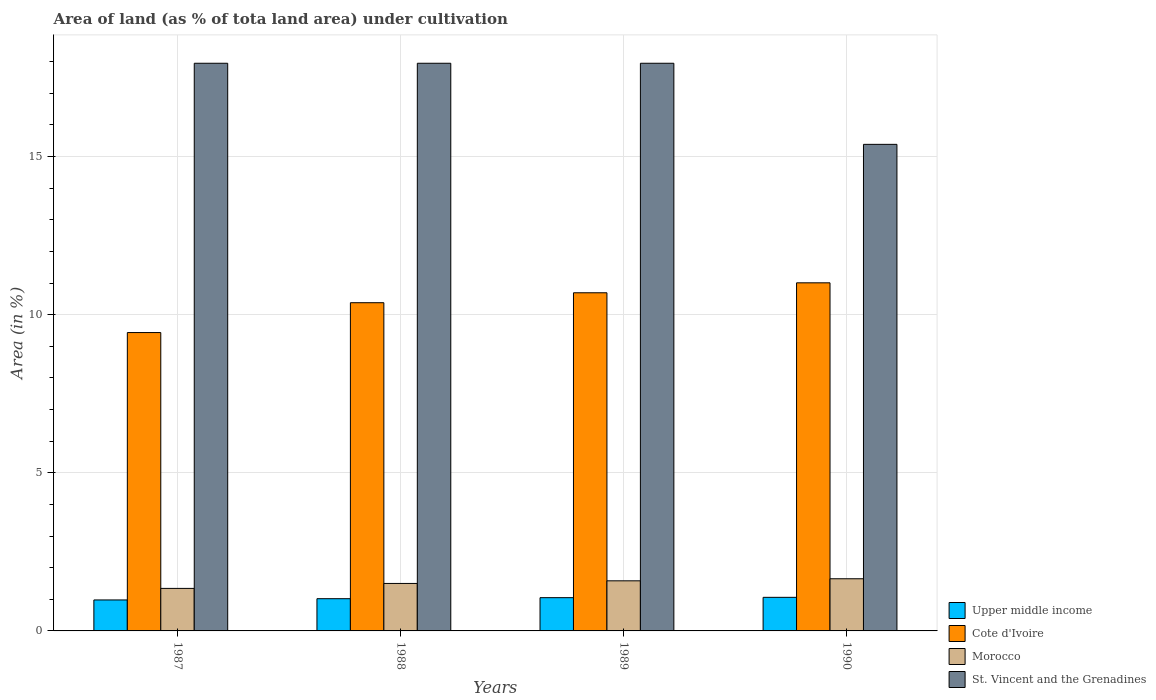Are the number of bars on each tick of the X-axis equal?
Your answer should be compact. Yes. What is the percentage of land under cultivation in Upper middle income in 1989?
Your answer should be very brief. 1.05. Across all years, what is the maximum percentage of land under cultivation in Cote d'Ivoire?
Provide a succinct answer. 11.01. Across all years, what is the minimum percentage of land under cultivation in Morocco?
Provide a short and direct response. 1.34. In which year was the percentage of land under cultivation in Upper middle income maximum?
Provide a short and direct response. 1990. In which year was the percentage of land under cultivation in Upper middle income minimum?
Your answer should be compact. 1987. What is the total percentage of land under cultivation in Upper middle income in the graph?
Offer a terse response. 4.11. What is the difference between the percentage of land under cultivation in Morocco in 1989 and that in 1990?
Keep it short and to the point. -0.06. What is the difference between the percentage of land under cultivation in Upper middle income in 1989 and the percentage of land under cultivation in St. Vincent and the Grenadines in 1990?
Your answer should be compact. -14.33. What is the average percentage of land under cultivation in Morocco per year?
Offer a very short reply. 1.52. In the year 1987, what is the difference between the percentage of land under cultivation in Morocco and percentage of land under cultivation in Upper middle income?
Give a very brief answer. 0.37. In how many years, is the percentage of land under cultivation in St. Vincent and the Grenadines greater than 9 %?
Your answer should be very brief. 4. What is the difference between the highest and the second highest percentage of land under cultivation in Morocco?
Provide a succinct answer. 0.06. What is the difference between the highest and the lowest percentage of land under cultivation in Morocco?
Offer a terse response. 0.3. Is the sum of the percentage of land under cultivation in Morocco in 1987 and 1989 greater than the maximum percentage of land under cultivation in Cote d'Ivoire across all years?
Your answer should be very brief. No. Is it the case that in every year, the sum of the percentage of land under cultivation in Morocco and percentage of land under cultivation in Cote d'Ivoire is greater than the sum of percentage of land under cultivation in St. Vincent and the Grenadines and percentage of land under cultivation in Upper middle income?
Offer a terse response. Yes. What does the 1st bar from the left in 1989 represents?
Provide a succinct answer. Upper middle income. What does the 4th bar from the right in 1988 represents?
Make the answer very short. Upper middle income. Is it the case that in every year, the sum of the percentage of land under cultivation in Morocco and percentage of land under cultivation in Upper middle income is greater than the percentage of land under cultivation in Cote d'Ivoire?
Offer a very short reply. No. Are the values on the major ticks of Y-axis written in scientific E-notation?
Ensure brevity in your answer.  No. Does the graph contain any zero values?
Keep it short and to the point. No. Where does the legend appear in the graph?
Keep it short and to the point. Bottom right. What is the title of the graph?
Give a very brief answer. Area of land (as % of tota land area) under cultivation. Does "Cayman Islands" appear as one of the legend labels in the graph?
Give a very brief answer. No. What is the label or title of the X-axis?
Keep it short and to the point. Years. What is the label or title of the Y-axis?
Offer a very short reply. Area (in %). What is the Area (in %) in Upper middle income in 1987?
Your answer should be very brief. 0.98. What is the Area (in %) of Cote d'Ivoire in 1987?
Make the answer very short. 9.43. What is the Area (in %) in Morocco in 1987?
Your answer should be very brief. 1.34. What is the Area (in %) of St. Vincent and the Grenadines in 1987?
Offer a terse response. 17.95. What is the Area (in %) of Upper middle income in 1988?
Your response must be concise. 1.02. What is the Area (in %) of Cote d'Ivoire in 1988?
Ensure brevity in your answer.  10.38. What is the Area (in %) in Morocco in 1988?
Offer a terse response. 1.5. What is the Area (in %) of St. Vincent and the Grenadines in 1988?
Offer a terse response. 17.95. What is the Area (in %) in Upper middle income in 1989?
Your answer should be very brief. 1.05. What is the Area (in %) in Cote d'Ivoire in 1989?
Your response must be concise. 10.69. What is the Area (in %) in Morocco in 1989?
Your answer should be compact. 1.58. What is the Area (in %) in St. Vincent and the Grenadines in 1989?
Provide a succinct answer. 17.95. What is the Area (in %) in Upper middle income in 1990?
Give a very brief answer. 1.06. What is the Area (in %) in Cote d'Ivoire in 1990?
Provide a succinct answer. 11.01. What is the Area (in %) of Morocco in 1990?
Offer a terse response. 1.65. What is the Area (in %) of St. Vincent and the Grenadines in 1990?
Make the answer very short. 15.38. Across all years, what is the maximum Area (in %) of Upper middle income?
Provide a short and direct response. 1.06. Across all years, what is the maximum Area (in %) of Cote d'Ivoire?
Keep it short and to the point. 11.01. Across all years, what is the maximum Area (in %) in Morocco?
Provide a succinct answer. 1.65. Across all years, what is the maximum Area (in %) in St. Vincent and the Grenadines?
Offer a very short reply. 17.95. Across all years, what is the minimum Area (in %) of Upper middle income?
Provide a succinct answer. 0.98. Across all years, what is the minimum Area (in %) in Cote d'Ivoire?
Your answer should be compact. 9.43. Across all years, what is the minimum Area (in %) in Morocco?
Keep it short and to the point. 1.34. Across all years, what is the minimum Area (in %) in St. Vincent and the Grenadines?
Your answer should be compact. 15.38. What is the total Area (in %) of Upper middle income in the graph?
Make the answer very short. 4.11. What is the total Area (in %) in Cote d'Ivoire in the graph?
Offer a terse response. 41.51. What is the total Area (in %) of Morocco in the graph?
Provide a succinct answer. 6.08. What is the total Area (in %) of St. Vincent and the Grenadines in the graph?
Make the answer very short. 69.23. What is the difference between the Area (in %) of Upper middle income in 1987 and that in 1988?
Offer a very short reply. -0.04. What is the difference between the Area (in %) in Cote d'Ivoire in 1987 and that in 1988?
Provide a short and direct response. -0.94. What is the difference between the Area (in %) of Morocco in 1987 and that in 1988?
Keep it short and to the point. -0.16. What is the difference between the Area (in %) in Upper middle income in 1987 and that in 1989?
Give a very brief answer. -0.07. What is the difference between the Area (in %) in Cote d'Ivoire in 1987 and that in 1989?
Give a very brief answer. -1.26. What is the difference between the Area (in %) of Morocco in 1987 and that in 1989?
Offer a very short reply. -0.24. What is the difference between the Area (in %) in St. Vincent and the Grenadines in 1987 and that in 1989?
Keep it short and to the point. 0. What is the difference between the Area (in %) in Upper middle income in 1987 and that in 1990?
Offer a terse response. -0.08. What is the difference between the Area (in %) of Cote d'Ivoire in 1987 and that in 1990?
Ensure brevity in your answer.  -1.57. What is the difference between the Area (in %) in Morocco in 1987 and that in 1990?
Provide a short and direct response. -0.3. What is the difference between the Area (in %) in St. Vincent and the Grenadines in 1987 and that in 1990?
Offer a terse response. 2.56. What is the difference between the Area (in %) of Upper middle income in 1988 and that in 1989?
Keep it short and to the point. -0.03. What is the difference between the Area (in %) of Cote d'Ivoire in 1988 and that in 1989?
Keep it short and to the point. -0.31. What is the difference between the Area (in %) in Morocco in 1988 and that in 1989?
Offer a terse response. -0.08. What is the difference between the Area (in %) of Upper middle income in 1988 and that in 1990?
Your answer should be compact. -0.04. What is the difference between the Area (in %) in Cote d'Ivoire in 1988 and that in 1990?
Keep it short and to the point. -0.63. What is the difference between the Area (in %) in Morocco in 1988 and that in 1990?
Keep it short and to the point. -0.15. What is the difference between the Area (in %) of St. Vincent and the Grenadines in 1988 and that in 1990?
Provide a short and direct response. 2.56. What is the difference between the Area (in %) of Upper middle income in 1989 and that in 1990?
Offer a terse response. -0.01. What is the difference between the Area (in %) of Cote d'Ivoire in 1989 and that in 1990?
Your answer should be very brief. -0.31. What is the difference between the Area (in %) of Morocco in 1989 and that in 1990?
Your answer should be very brief. -0.07. What is the difference between the Area (in %) of St. Vincent and the Grenadines in 1989 and that in 1990?
Offer a terse response. 2.56. What is the difference between the Area (in %) of Upper middle income in 1987 and the Area (in %) of Cote d'Ivoire in 1988?
Your answer should be compact. -9.4. What is the difference between the Area (in %) in Upper middle income in 1987 and the Area (in %) in Morocco in 1988?
Offer a very short reply. -0.52. What is the difference between the Area (in %) of Upper middle income in 1987 and the Area (in %) of St. Vincent and the Grenadines in 1988?
Make the answer very short. -16.97. What is the difference between the Area (in %) of Cote d'Ivoire in 1987 and the Area (in %) of Morocco in 1988?
Offer a very short reply. 7.93. What is the difference between the Area (in %) in Cote d'Ivoire in 1987 and the Area (in %) in St. Vincent and the Grenadines in 1988?
Your answer should be compact. -8.51. What is the difference between the Area (in %) in Morocco in 1987 and the Area (in %) in St. Vincent and the Grenadines in 1988?
Make the answer very short. -16.6. What is the difference between the Area (in %) in Upper middle income in 1987 and the Area (in %) in Cote d'Ivoire in 1989?
Offer a terse response. -9.71. What is the difference between the Area (in %) in Upper middle income in 1987 and the Area (in %) in Morocco in 1989?
Your response must be concise. -0.6. What is the difference between the Area (in %) in Upper middle income in 1987 and the Area (in %) in St. Vincent and the Grenadines in 1989?
Provide a short and direct response. -16.97. What is the difference between the Area (in %) in Cote d'Ivoire in 1987 and the Area (in %) in Morocco in 1989?
Ensure brevity in your answer.  7.85. What is the difference between the Area (in %) of Cote d'Ivoire in 1987 and the Area (in %) of St. Vincent and the Grenadines in 1989?
Your response must be concise. -8.51. What is the difference between the Area (in %) of Morocco in 1987 and the Area (in %) of St. Vincent and the Grenadines in 1989?
Your answer should be compact. -16.6. What is the difference between the Area (in %) of Upper middle income in 1987 and the Area (in %) of Cote d'Ivoire in 1990?
Provide a short and direct response. -10.03. What is the difference between the Area (in %) of Upper middle income in 1987 and the Area (in %) of Morocco in 1990?
Provide a short and direct response. -0.67. What is the difference between the Area (in %) of Upper middle income in 1987 and the Area (in %) of St. Vincent and the Grenadines in 1990?
Provide a short and direct response. -14.41. What is the difference between the Area (in %) in Cote d'Ivoire in 1987 and the Area (in %) in Morocco in 1990?
Give a very brief answer. 7.78. What is the difference between the Area (in %) in Cote d'Ivoire in 1987 and the Area (in %) in St. Vincent and the Grenadines in 1990?
Provide a succinct answer. -5.95. What is the difference between the Area (in %) in Morocco in 1987 and the Area (in %) in St. Vincent and the Grenadines in 1990?
Offer a very short reply. -14.04. What is the difference between the Area (in %) of Upper middle income in 1988 and the Area (in %) of Cote d'Ivoire in 1989?
Ensure brevity in your answer.  -9.67. What is the difference between the Area (in %) of Upper middle income in 1988 and the Area (in %) of Morocco in 1989?
Your answer should be compact. -0.57. What is the difference between the Area (in %) in Upper middle income in 1988 and the Area (in %) in St. Vincent and the Grenadines in 1989?
Offer a terse response. -16.93. What is the difference between the Area (in %) in Cote d'Ivoire in 1988 and the Area (in %) in Morocco in 1989?
Offer a very short reply. 8.79. What is the difference between the Area (in %) of Cote d'Ivoire in 1988 and the Area (in %) of St. Vincent and the Grenadines in 1989?
Offer a very short reply. -7.57. What is the difference between the Area (in %) of Morocco in 1988 and the Area (in %) of St. Vincent and the Grenadines in 1989?
Your answer should be very brief. -16.45. What is the difference between the Area (in %) in Upper middle income in 1988 and the Area (in %) in Cote d'Ivoire in 1990?
Your response must be concise. -9.99. What is the difference between the Area (in %) in Upper middle income in 1988 and the Area (in %) in Morocco in 1990?
Ensure brevity in your answer.  -0.63. What is the difference between the Area (in %) in Upper middle income in 1988 and the Area (in %) in St. Vincent and the Grenadines in 1990?
Your answer should be compact. -14.37. What is the difference between the Area (in %) of Cote d'Ivoire in 1988 and the Area (in %) of Morocco in 1990?
Your answer should be very brief. 8.73. What is the difference between the Area (in %) of Cote d'Ivoire in 1988 and the Area (in %) of St. Vincent and the Grenadines in 1990?
Your answer should be very brief. -5.01. What is the difference between the Area (in %) of Morocco in 1988 and the Area (in %) of St. Vincent and the Grenadines in 1990?
Your answer should be compact. -13.88. What is the difference between the Area (in %) in Upper middle income in 1989 and the Area (in %) in Cote d'Ivoire in 1990?
Offer a terse response. -9.95. What is the difference between the Area (in %) of Upper middle income in 1989 and the Area (in %) of Morocco in 1990?
Give a very brief answer. -0.6. What is the difference between the Area (in %) of Upper middle income in 1989 and the Area (in %) of St. Vincent and the Grenadines in 1990?
Ensure brevity in your answer.  -14.33. What is the difference between the Area (in %) of Cote d'Ivoire in 1989 and the Area (in %) of Morocco in 1990?
Make the answer very short. 9.04. What is the difference between the Area (in %) of Cote d'Ivoire in 1989 and the Area (in %) of St. Vincent and the Grenadines in 1990?
Your answer should be compact. -4.69. What is the difference between the Area (in %) of Morocco in 1989 and the Area (in %) of St. Vincent and the Grenadines in 1990?
Give a very brief answer. -13.8. What is the average Area (in %) in Upper middle income per year?
Provide a succinct answer. 1.03. What is the average Area (in %) in Cote d'Ivoire per year?
Your answer should be compact. 10.38. What is the average Area (in %) in Morocco per year?
Your answer should be compact. 1.52. What is the average Area (in %) in St. Vincent and the Grenadines per year?
Ensure brevity in your answer.  17.31. In the year 1987, what is the difference between the Area (in %) in Upper middle income and Area (in %) in Cote d'Ivoire?
Your answer should be very brief. -8.45. In the year 1987, what is the difference between the Area (in %) of Upper middle income and Area (in %) of Morocco?
Provide a short and direct response. -0.36. In the year 1987, what is the difference between the Area (in %) in Upper middle income and Area (in %) in St. Vincent and the Grenadines?
Offer a terse response. -16.97. In the year 1987, what is the difference between the Area (in %) of Cote d'Ivoire and Area (in %) of Morocco?
Ensure brevity in your answer.  8.09. In the year 1987, what is the difference between the Area (in %) of Cote d'Ivoire and Area (in %) of St. Vincent and the Grenadines?
Give a very brief answer. -8.51. In the year 1987, what is the difference between the Area (in %) in Morocco and Area (in %) in St. Vincent and the Grenadines?
Provide a succinct answer. -16.6. In the year 1988, what is the difference between the Area (in %) in Upper middle income and Area (in %) in Cote d'Ivoire?
Your answer should be very brief. -9.36. In the year 1988, what is the difference between the Area (in %) in Upper middle income and Area (in %) in Morocco?
Provide a succinct answer. -0.48. In the year 1988, what is the difference between the Area (in %) in Upper middle income and Area (in %) in St. Vincent and the Grenadines?
Offer a terse response. -16.93. In the year 1988, what is the difference between the Area (in %) of Cote d'Ivoire and Area (in %) of Morocco?
Keep it short and to the point. 8.88. In the year 1988, what is the difference between the Area (in %) of Cote d'Ivoire and Area (in %) of St. Vincent and the Grenadines?
Give a very brief answer. -7.57. In the year 1988, what is the difference between the Area (in %) of Morocco and Area (in %) of St. Vincent and the Grenadines?
Offer a terse response. -16.45. In the year 1989, what is the difference between the Area (in %) of Upper middle income and Area (in %) of Cote d'Ivoire?
Provide a short and direct response. -9.64. In the year 1989, what is the difference between the Area (in %) of Upper middle income and Area (in %) of Morocco?
Give a very brief answer. -0.53. In the year 1989, what is the difference between the Area (in %) of Upper middle income and Area (in %) of St. Vincent and the Grenadines?
Provide a succinct answer. -16.9. In the year 1989, what is the difference between the Area (in %) of Cote d'Ivoire and Area (in %) of Morocco?
Keep it short and to the point. 9.11. In the year 1989, what is the difference between the Area (in %) in Cote d'Ivoire and Area (in %) in St. Vincent and the Grenadines?
Provide a short and direct response. -7.26. In the year 1989, what is the difference between the Area (in %) in Morocco and Area (in %) in St. Vincent and the Grenadines?
Offer a very short reply. -16.36. In the year 1990, what is the difference between the Area (in %) in Upper middle income and Area (in %) in Cote d'Ivoire?
Provide a succinct answer. -9.94. In the year 1990, what is the difference between the Area (in %) in Upper middle income and Area (in %) in Morocco?
Your response must be concise. -0.59. In the year 1990, what is the difference between the Area (in %) in Upper middle income and Area (in %) in St. Vincent and the Grenadines?
Make the answer very short. -14.32. In the year 1990, what is the difference between the Area (in %) in Cote d'Ivoire and Area (in %) in Morocco?
Offer a very short reply. 9.36. In the year 1990, what is the difference between the Area (in %) in Cote d'Ivoire and Area (in %) in St. Vincent and the Grenadines?
Give a very brief answer. -4.38. In the year 1990, what is the difference between the Area (in %) of Morocco and Area (in %) of St. Vincent and the Grenadines?
Offer a terse response. -13.74. What is the ratio of the Area (in %) of Upper middle income in 1987 to that in 1988?
Make the answer very short. 0.96. What is the ratio of the Area (in %) in Morocco in 1987 to that in 1988?
Provide a succinct answer. 0.9. What is the ratio of the Area (in %) of Upper middle income in 1987 to that in 1989?
Make the answer very short. 0.93. What is the ratio of the Area (in %) of Cote d'Ivoire in 1987 to that in 1989?
Offer a terse response. 0.88. What is the ratio of the Area (in %) of Morocco in 1987 to that in 1989?
Offer a terse response. 0.85. What is the ratio of the Area (in %) in St. Vincent and the Grenadines in 1987 to that in 1989?
Offer a terse response. 1. What is the ratio of the Area (in %) in Upper middle income in 1987 to that in 1990?
Your answer should be compact. 0.92. What is the ratio of the Area (in %) of Morocco in 1987 to that in 1990?
Provide a short and direct response. 0.82. What is the ratio of the Area (in %) of Upper middle income in 1988 to that in 1989?
Your answer should be very brief. 0.97. What is the ratio of the Area (in %) of Cote d'Ivoire in 1988 to that in 1989?
Provide a succinct answer. 0.97. What is the ratio of the Area (in %) in Morocco in 1988 to that in 1989?
Your answer should be compact. 0.95. What is the ratio of the Area (in %) of St. Vincent and the Grenadines in 1988 to that in 1989?
Make the answer very short. 1. What is the ratio of the Area (in %) of Upper middle income in 1988 to that in 1990?
Your answer should be compact. 0.96. What is the ratio of the Area (in %) of Cote d'Ivoire in 1988 to that in 1990?
Give a very brief answer. 0.94. What is the ratio of the Area (in %) in Morocco in 1988 to that in 1990?
Your answer should be compact. 0.91. What is the ratio of the Area (in %) of St. Vincent and the Grenadines in 1988 to that in 1990?
Your response must be concise. 1.17. What is the ratio of the Area (in %) in Upper middle income in 1989 to that in 1990?
Offer a very short reply. 0.99. What is the ratio of the Area (in %) of Cote d'Ivoire in 1989 to that in 1990?
Your response must be concise. 0.97. What is the ratio of the Area (in %) of Morocco in 1989 to that in 1990?
Your response must be concise. 0.96. What is the difference between the highest and the second highest Area (in %) of Upper middle income?
Provide a succinct answer. 0.01. What is the difference between the highest and the second highest Area (in %) of Cote d'Ivoire?
Your answer should be compact. 0.31. What is the difference between the highest and the second highest Area (in %) of Morocco?
Make the answer very short. 0.07. What is the difference between the highest and the second highest Area (in %) of St. Vincent and the Grenadines?
Ensure brevity in your answer.  0. What is the difference between the highest and the lowest Area (in %) in Upper middle income?
Make the answer very short. 0.08. What is the difference between the highest and the lowest Area (in %) in Cote d'Ivoire?
Give a very brief answer. 1.57. What is the difference between the highest and the lowest Area (in %) of Morocco?
Provide a succinct answer. 0.3. What is the difference between the highest and the lowest Area (in %) of St. Vincent and the Grenadines?
Offer a terse response. 2.56. 